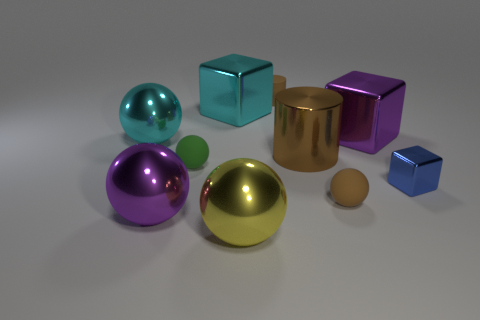Subtract all blue balls. Subtract all brown cubes. How many balls are left? 5 Subtract all cubes. How many objects are left? 7 Add 5 small things. How many small things are left? 9 Add 3 cubes. How many cubes exist? 6 Subtract 0 gray spheres. How many objects are left? 10 Subtract all big yellow metal blocks. Subtract all large purple metallic objects. How many objects are left? 8 